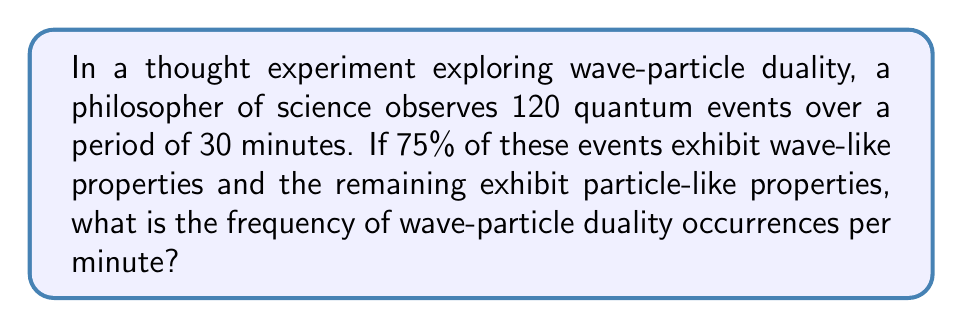Can you solve this math problem? To solve this problem, we need to follow these steps:

1. Calculate the total number of wave-particle duality occurrences:
   Since all observed events exhibit either wave-like or particle-like properties, each event represents a wave-particle duality occurrence. Therefore, the total number of occurrences is 120.

2. Calculate the frequency:
   Frequency is defined as the number of occurrences divided by the time period.

   Let's use the formula:
   $$ f = \frac{n}{t} $$
   Where:
   $f$ = frequency
   $n$ = number of occurrences
   $t$ = time period

   Substituting our values:
   $$ f = \frac{120 \text{ occurrences}}{30 \text{ minutes}} $$

3. Simplify the fraction:
   $$ f = \frac{120}{30} = 4 \text{ occurrences per minute} $$

Thus, the frequency of wave-particle duality occurrences is 4 per minute.
Answer: $4 \text{ occurrences per minute}$ 